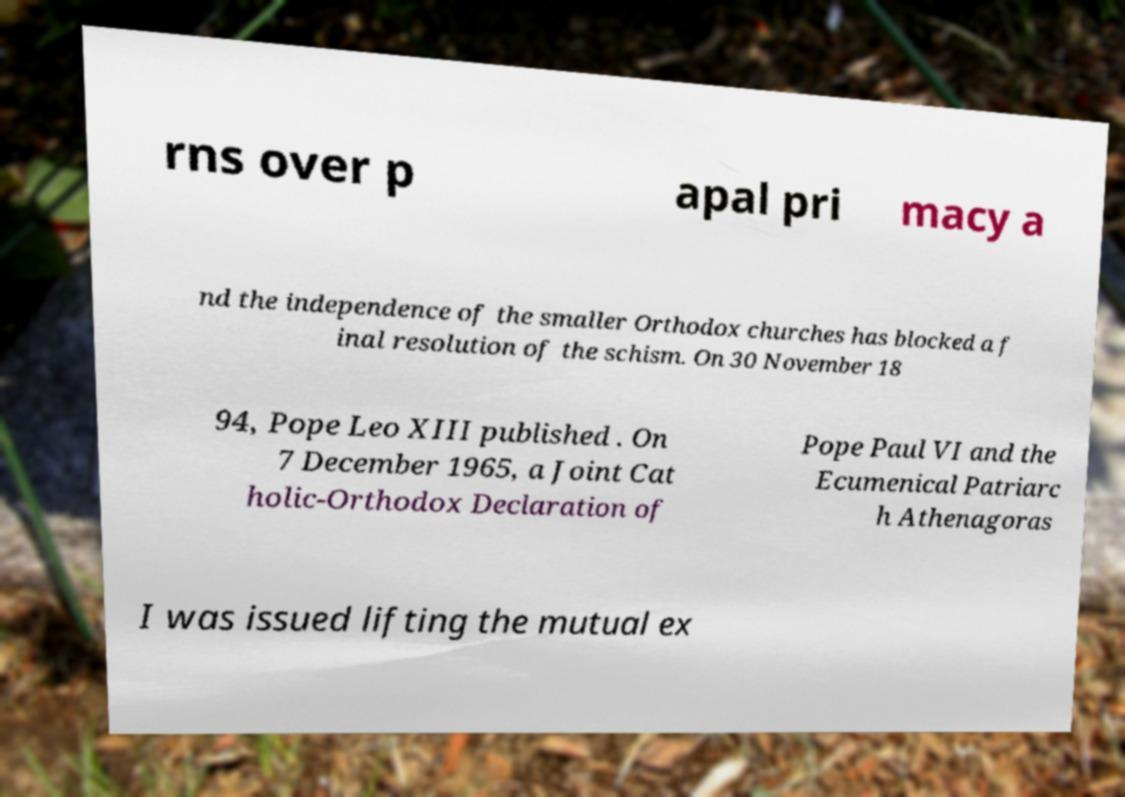Can you accurately transcribe the text from the provided image for me? rns over p apal pri macy a nd the independence of the smaller Orthodox churches has blocked a f inal resolution of the schism. On 30 November 18 94, Pope Leo XIII published . On 7 December 1965, a Joint Cat holic-Orthodox Declaration of Pope Paul VI and the Ecumenical Patriarc h Athenagoras I was issued lifting the mutual ex 